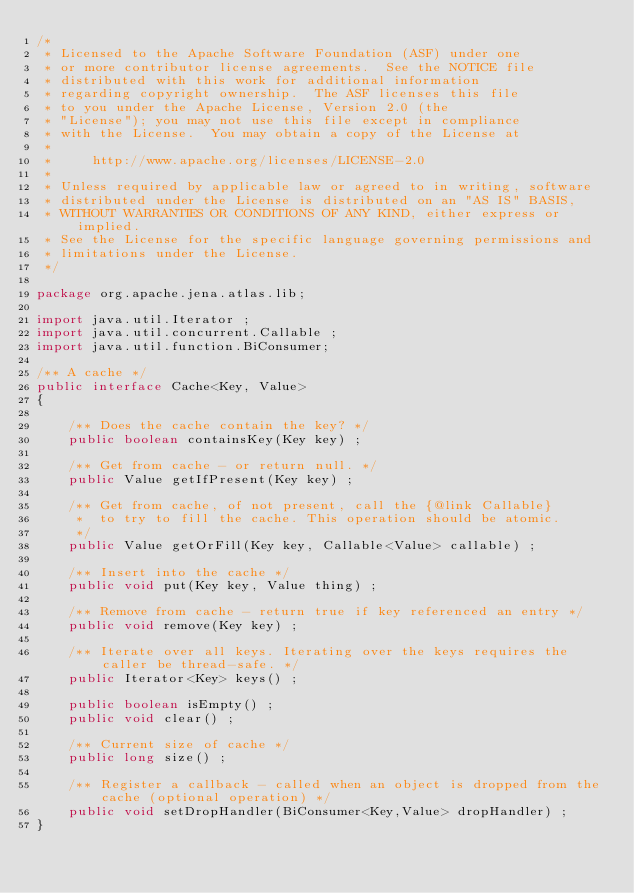<code> <loc_0><loc_0><loc_500><loc_500><_Java_>/*
 * Licensed to the Apache Software Foundation (ASF) under one
 * or more contributor license agreements.  See the NOTICE file
 * distributed with this work for additional information
 * regarding copyright ownership.  The ASF licenses this file
 * to you under the Apache License, Version 2.0 (the
 * "License"); you may not use this file except in compliance
 * with the License.  You may obtain a copy of the License at
 *
 *     http://www.apache.org/licenses/LICENSE-2.0
 *
 * Unless required by applicable law or agreed to in writing, software
 * distributed under the License is distributed on an "AS IS" BASIS,
 * WITHOUT WARRANTIES OR CONDITIONS OF ANY KIND, either express or implied.
 * See the License for the specific language governing permissions and
 * limitations under the License.
 */

package org.apache.jena.atlas.lib;

import java.util.Iterator ;
import java.util.concurrent.Callable ;
import java.util.function.BiConsumer;

/** A cache */
public interface Cache<Key, Value>
{
    
    /** Does the cache contain the key? */
    public boolean containsKey(Key key) ;
    
    /** Get from cache - or return null. */  
    public Value getIfPresent(Key key) ;
    
    /** Get from cache, of not present, call the {@link Callable}
     *  to try to fill the cache. This operation should be atomic.
     */
    public Value getOrFill(Key key, Callable<Value> callable) ;

    /** Insert into the cache */
    public void put(Key key, Value thing) ;

    /** Remove from cache - return true if key referenced an entry */
    public void remove(Key key) ;
    
    /** Iterate over all keys. Iterating over the keys requires the caller be thread-safe. */ 
    public Iterator<Key> keys() ;
    
    public boolean isEmpty() ;
    public void clear() ;
    
    /** Current size of cache */
    public long size() ;
    
    /** Register a callback - called when an object is dropped from the cache (optional operation) */ 
    public void setDropHandler(BiConsumer<Key,Value> dropHandler) ;
}
</code> 